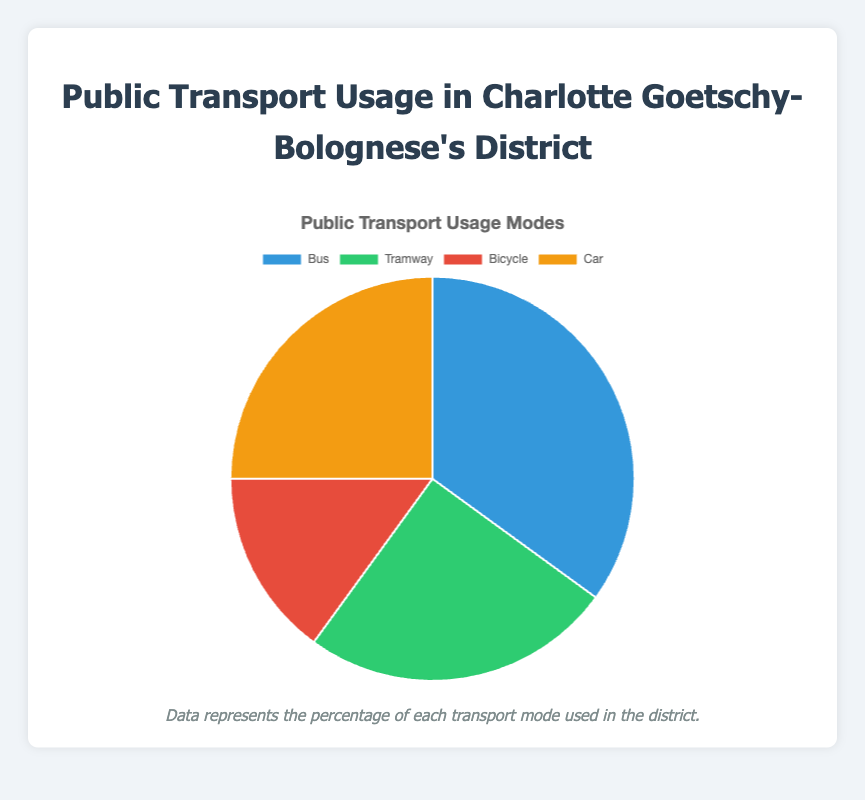Which transport mode is used the most? The transport mode with the highest percentage is the one used the most. Here, it is the bus with 35%.
Answer: Bus Are there any transport modes that have the same usage percentage? We compare the percentages and notice that Tramway and Car both have a usage of 25%.
Answer: Tramway and Car What is the total percentage for all public transport modes excluding the car? By adding the percentages for Bus, Tramway, and Bicycle: 35% + 25% + 15% = 75%. Therefore, total percentage excluding car usage is 75%.
Answer: 75% What is the difference in percentage between bus and bicycle usage? Subtract the bicycle usage from the bus usage: 35% - 15% = 20%. Therefore, the difference is 20%.
Answer: 20% Which transport mode occupies the smallest segment of the pie chart? The transport mode with the smallest percentage is the bicycle with 15%.
Answer: Bicycle How much more popular is the bus compared to the tramway? Subtract the tramway usage from the bus usage: 35% - 25% = 10%. Therefore, the bus is 10% more popular.
Answer: 10% If we combine the percentages for bicycle and car usage, how does it compare to the bus usage? The combined percentage for bicycle and car is: 15% + 25% = 40%. Comparing this with the bus, 40% is larger than 35%.
Answer: 40% is larger What are the colors used to represent bus and bicycle in the pie chart? In the visual representation, bus is shown in blue and bicycle is shown in red.
Answer: Blue for bus and Red for bicycle What percentage of the transport modes are motor-based (bus, tramway, car)? By adding the percentages for Bus, Tramway, and Car: 35% + 25% + 25% = 85%. Hence, 85% are motor-based.
Answer: 85% What is the combined percentage for non-motor-based transport modes? Only bicycle is non-motor-based with a percentage of 15%.
Answer: 15% 